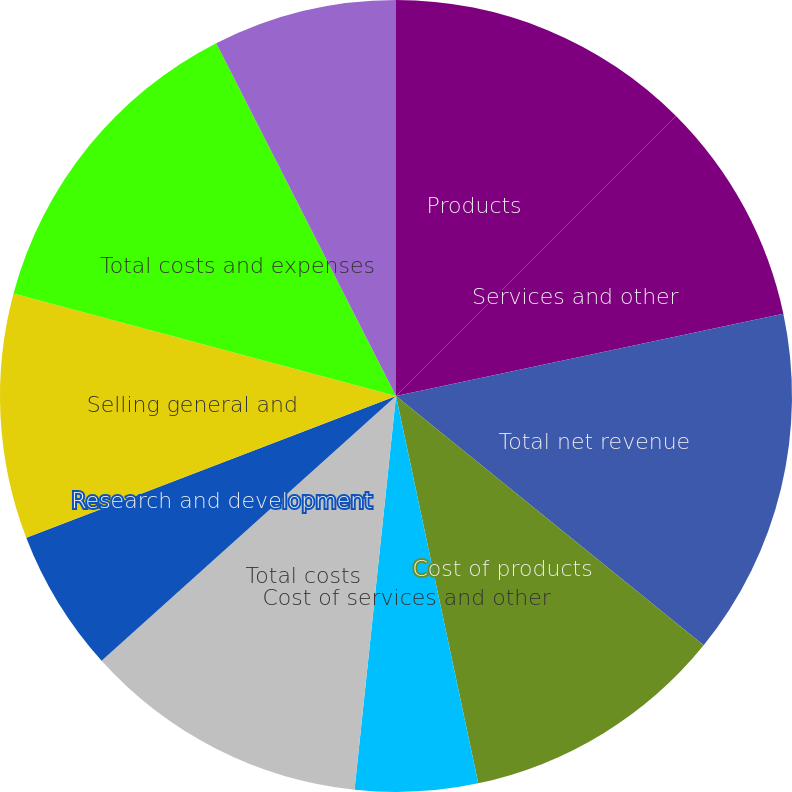Convert chart to OTSL. <chart><loc_0><loc_0><loc_500><loc_500><pie_chart><fcel>Products<fcel>Services and other<fcel>Total net revenue<fcel>Cost of products<fcel>Cost of services and other<fcel>Total costs<fcel>Research and development<fcel>Selling general and<fcel>Total costs and expenses<fcel>Income from operations<nl><fcel>12.5%<fcel>9.17%<fcel>14.17%<fcel>10.83%<fcel>5.0%<fcel>11.67%<fcel>5.83%<fcel>10.0%<fcel>13.33%<fcel>7.5%<nl></chart> 